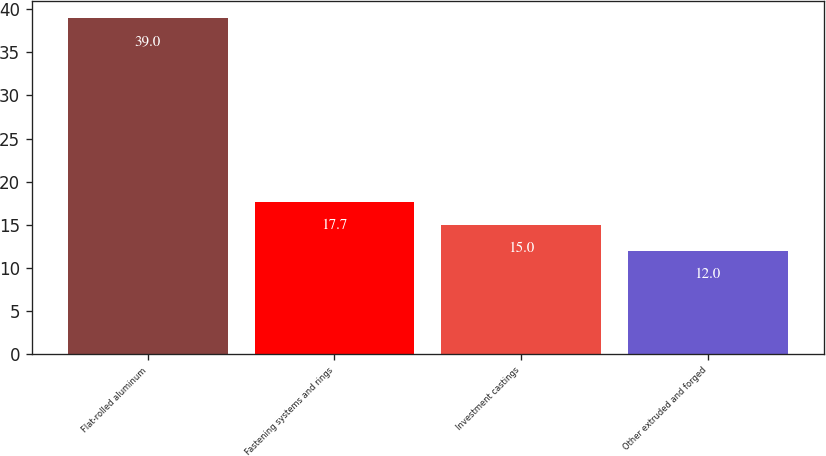<chart> <loc_0><loc_0><loc_500><loc_500><bar_chart><fcel>Flat-rolled aluminum<fcel>Fastening systems and rings<fcel>Investment castings<fcel>Other extruded and forged<nl><fcel>39<fcel>17.7<fcel>15<fcel>12<nl></chart> 